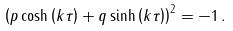Convert formula to latex. <formula><loc_0><loc_0><loc_500><loc_500>\left ( { p \cosh \left ( { k \tau } \right ) + q \sinh \left ( { k \tau } \right ) } \right ) ^ { 2 } = - 1 \, .</formula> 